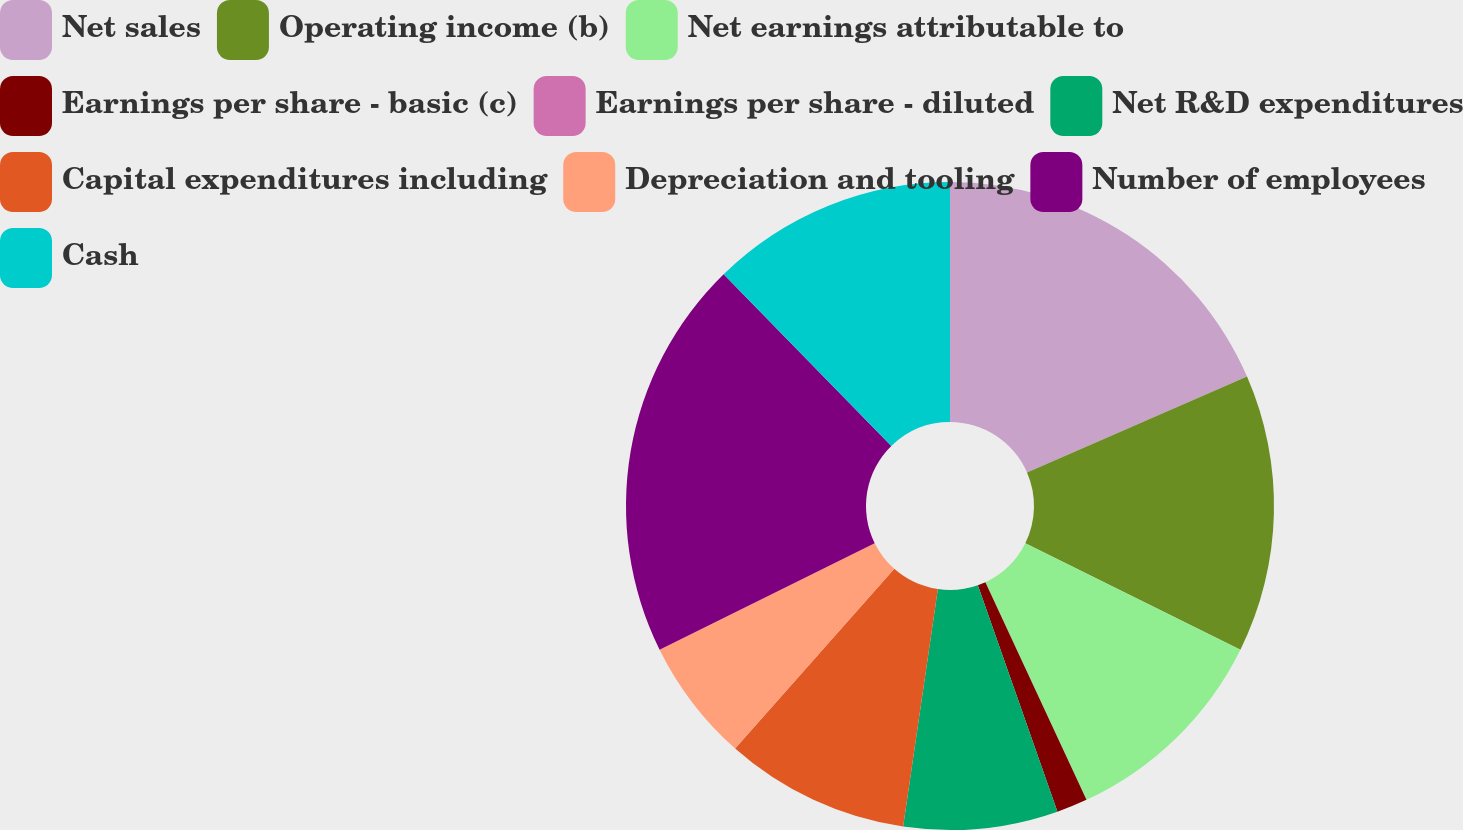<chart> <loc_0><loc_0><loc_500><loc_500><pie_chart><fcel>Net sales<fcel>Operating income (b)<fcel>Net earnings attributable to<fcel>Earnings per share - basic (c)<fcel>Earnings per share - diluted<fcel>Net R&D expenditures<fcel>Capital expenditures including<fcel>Depreciation and tooling<fcel>Number of employees<fcel>Cash<nl><fcel>18.46%<fcel>13.85%<fcel>10.77%<fcel>1.54%<fcel>0.0%<fcel>7.69%<fcel>9.23%<fcel>6.15%<fcel>20.0%<fcel>12.31%<nl></chart> 